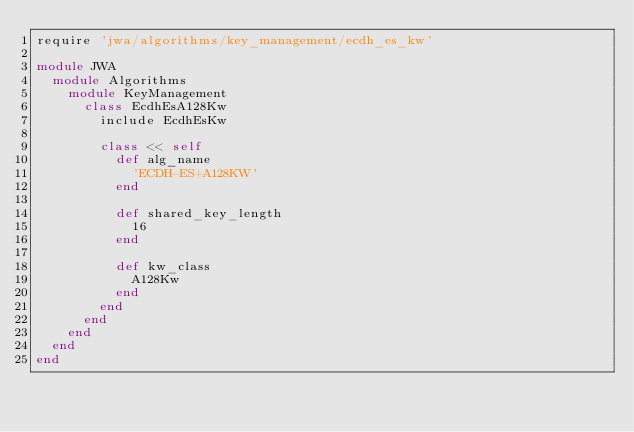Convert code to text. <code><loc_0><loc_0><loc_500><loc_500><_Ruby_>require 'jwa/algorithms/key_management/ecdh_es_kw'

module JWA
  module Algorithms
    module KeyManagement
      class EcdhEsA128Kw
        include EcdhEsKw

        class << self
          def alg_name
            'ECDH-ES+A128KW'
          end

          def shared_key_length
            16
          end

          def kw_class
            A128Kw
          end
        end
      end
    end
  end
end
</code> 